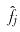Convert formula to latex. <formula><loc_0><loc_0><loc_500><loc_500>\hat { f _ { j } }</formula> 